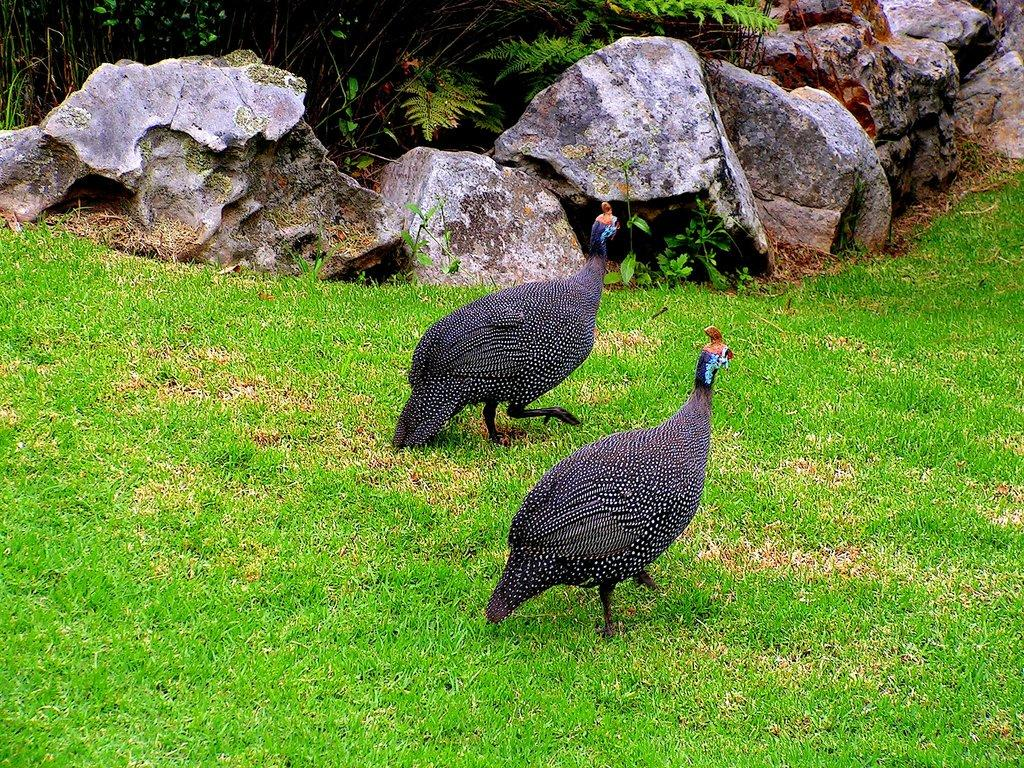What type of animals are on the ground in the image? There are birds on the ground in the image. What is the ground covered with? The ground is covered with grass. What other objects can be seen on the ground? There are stones visible in the image. What type of vegetation is present in the image? There are plants in the image. What type of desk is visible in the image? There is no desk present in the image. What area of land do the birds claim as their own in the image? The birds do not claim any territory in the image; they are simply on the ground. 